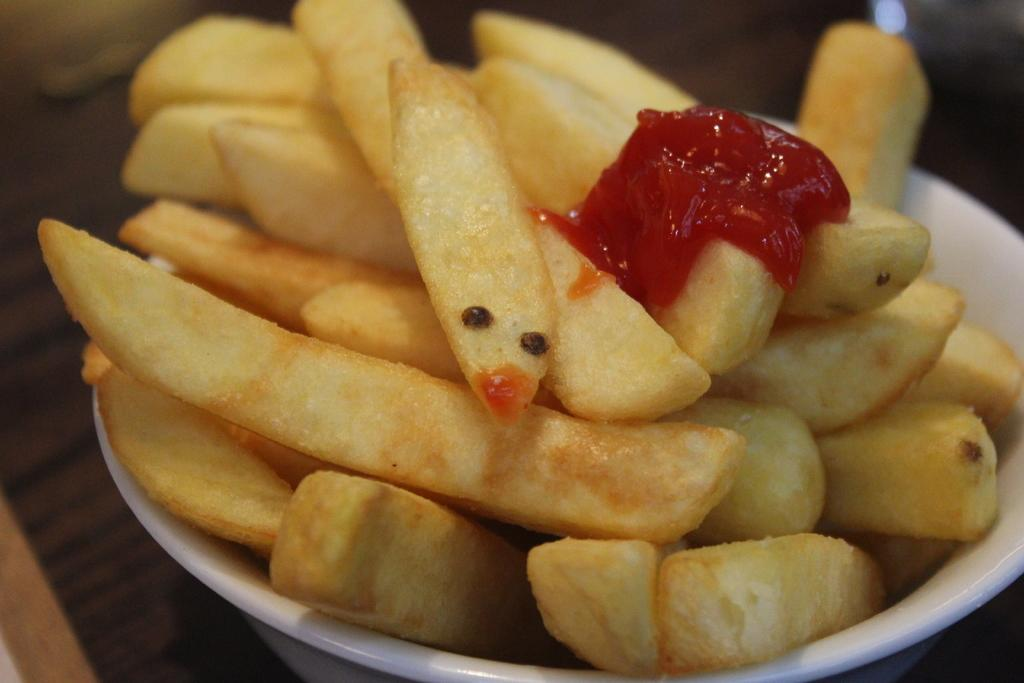What types of items can be seen in the image? There are food items in the image. How are the food items arranged or presented? The food items are served in a container. How many boats are visible in the image? There are no boats present in the image. What type of system is being used to grip the food items in the image? There is no system or grip mechanism visible in the image; the food items are simply served in a container. 